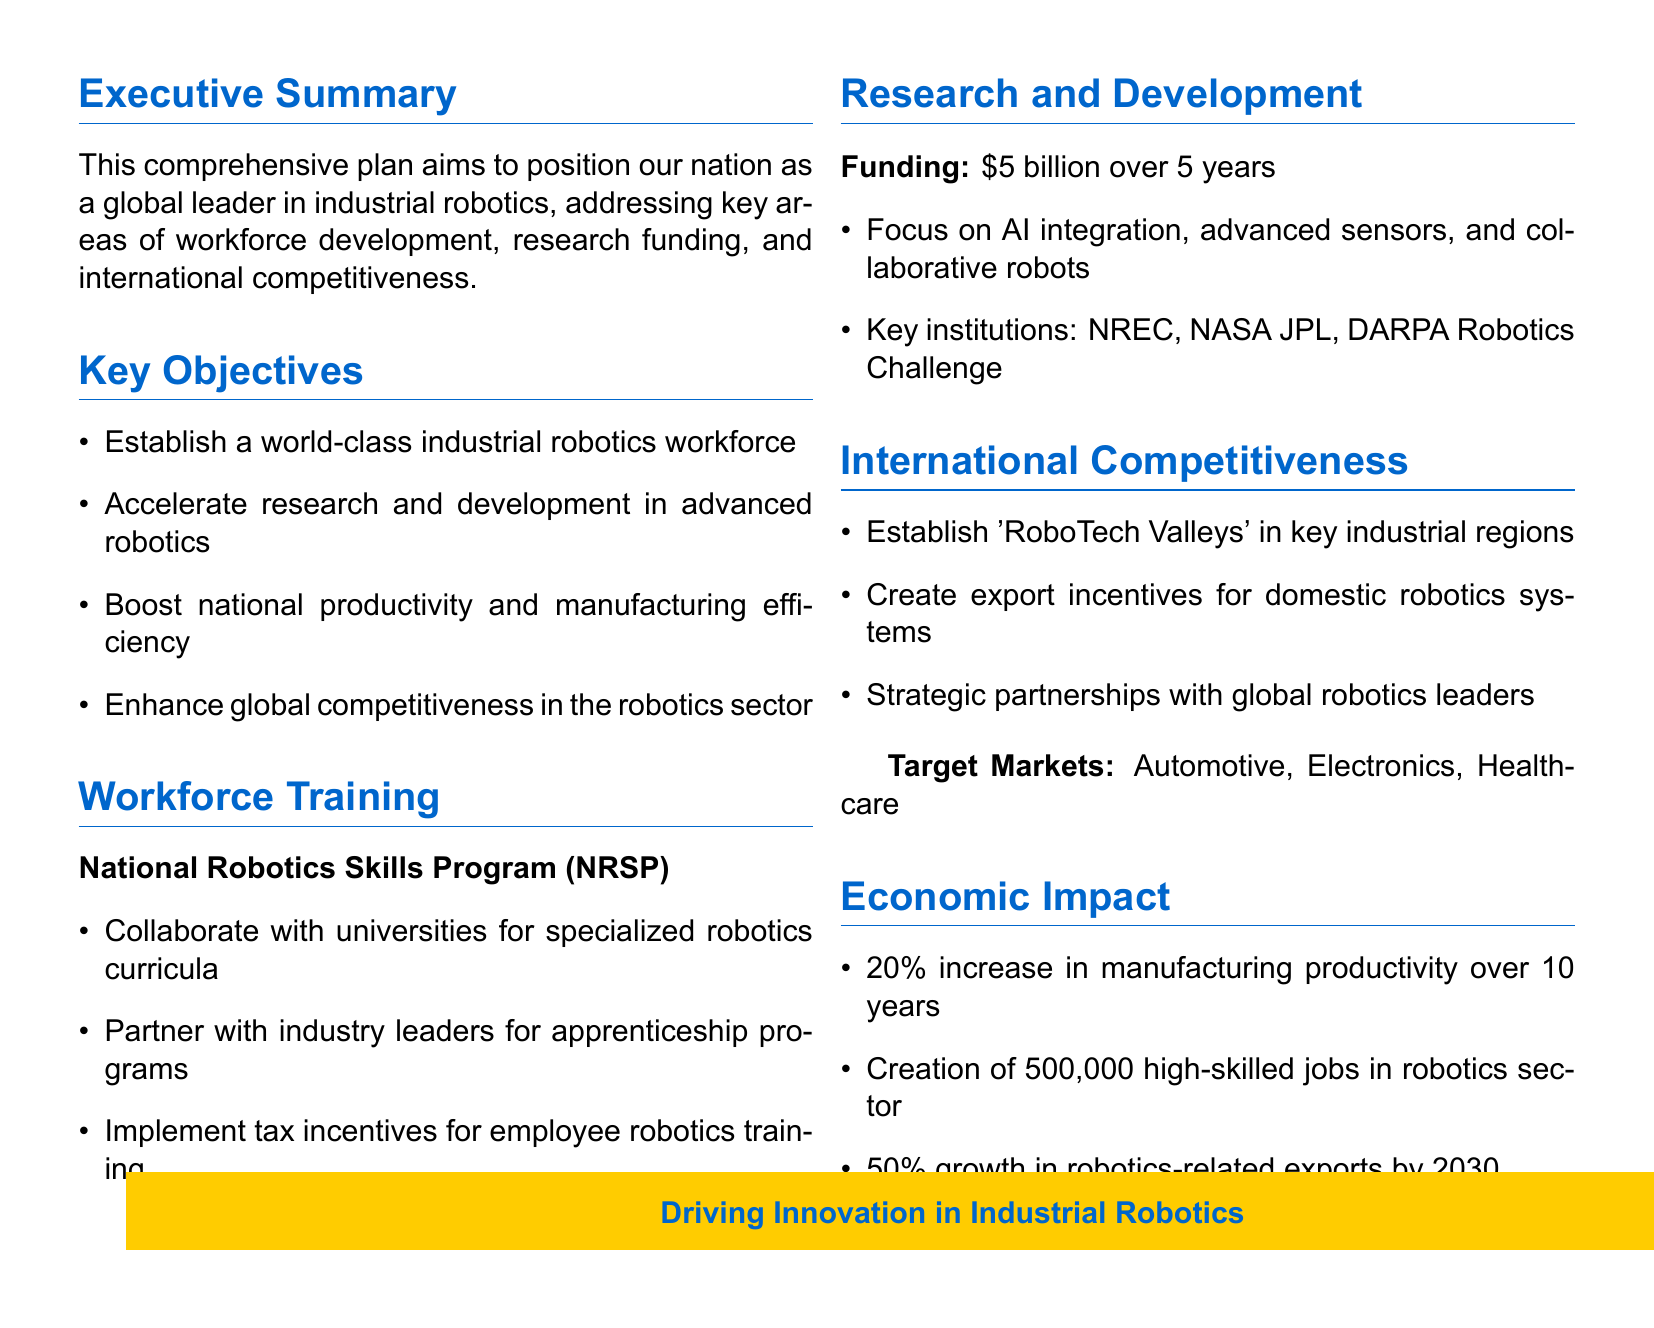What is the total funding for research and development? The total funding allocated for research and development over five years is stated in the document as $5 billion.
Answer: $5 billion What are the target markets mentioned? The document specifies three target markets: Automotive, Electronics, and Healthcare.
Answer: Automotive, Electronics, Healthcare How many high-skilled jobs are expected to be created? The document mentions the creation of 500,000 high-skilled jobs in the robotics sector as a result of the plan.
Answer: 500,000 What is the expected increase in manufacturing productivity over 10 years? The document indicates a 20% increase in manufacturing productivity is expected over the next 10 years.
Answer: 20% What program is established for workforce training? The document outlines the National Robotics Skills Program (NRSP) as the initiative aimed at workforce training.
Answer: National Robotics Skills Program (NRSP) Which key institutions are involved in research and development? The document lists NREC, NASA JPL, and DARPA Robotics Challenge as key institutions for research and development funding.
Answer: NREC, NASA JPL, DARPA Robotics Challenge What is one of the objectives regarding global competitiveness? The document states that one of the objectives is to enhance global competitiveness in the robotics sector.
Answer: Enhance global competitiveness in the robotics sector What type of incentives will be created for domestic robotics systems? The document mentions the creation of export incentives for domestic robotics systems as part of the competitiveness strategy.
Answer: Export incentives for domestic robotics systems 